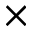<formula> <loc_0><loc_0><loc_500><loc_500>\times</formula> 